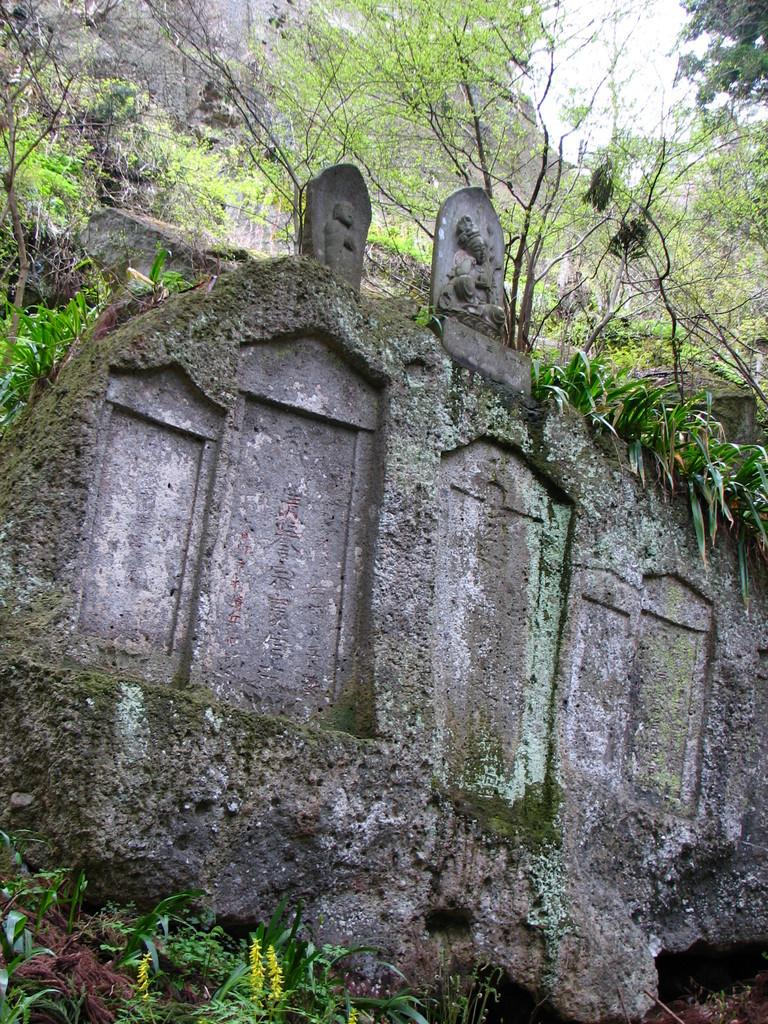What is present on the wall in the image? There is a statue on the wall in the image. What can be seen in the background of the image? There are trees, a mountain, and the sky visible in the background of the image. What type of steel is used to construct the army vehicles in the image? There are no army vehicles or steel present in the image. Can you describe the driving conditions in the image? There is no driving or vehicles present in the image. 